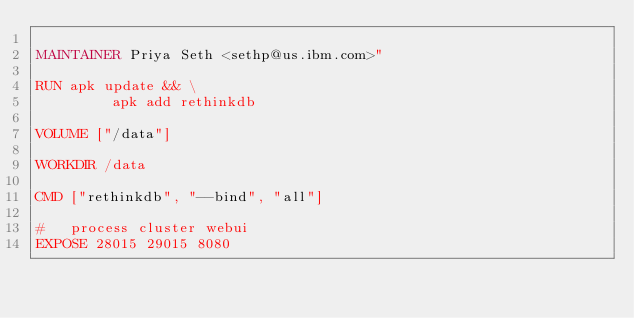Convert code to text. <code><loc_0><loc_0><loc_500><loc_500><_Dockerfile_>
MAINTAINER Priya Seth <sethp@us.ibm.com>"

RUN apk update && \
         apk add rethinkdb

VOLUME ["/data"]

WORKDIR /data

CMD ["rethinkdb", "--bind", "all"]

#   process cluster webui
EXPOSE 28015 29015 8080

</code> 